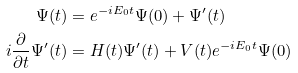<formula> <loc_0><loc_0><loc_500><loc_500>\Psi ( t ) & = e ^ { - i E _ { 0 } t } \Psi ( 0 ) + \Psi ^ { \prime } ( t ) \\ i \frac { \partial } { \partial t } \Psi ^ { \prime } ( t ) & = H ( t ) \Psi ^ { \prime } ( t ) + V ( t ) e ^ { - i E _ { 0 } t } \Psi ( 0 )</formula> 